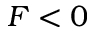Convert formula to latex. <formula><loc_0><loc_0><loc_500><loc_500>F < 0</formula> 